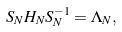Convert formula to latex. <formula><loc_0><loc_0><loc_500><loc_500>S _ { N } H _ { N } S _ { N } ^ { - 1 } = \Lambda _ { N } ,</formula> 